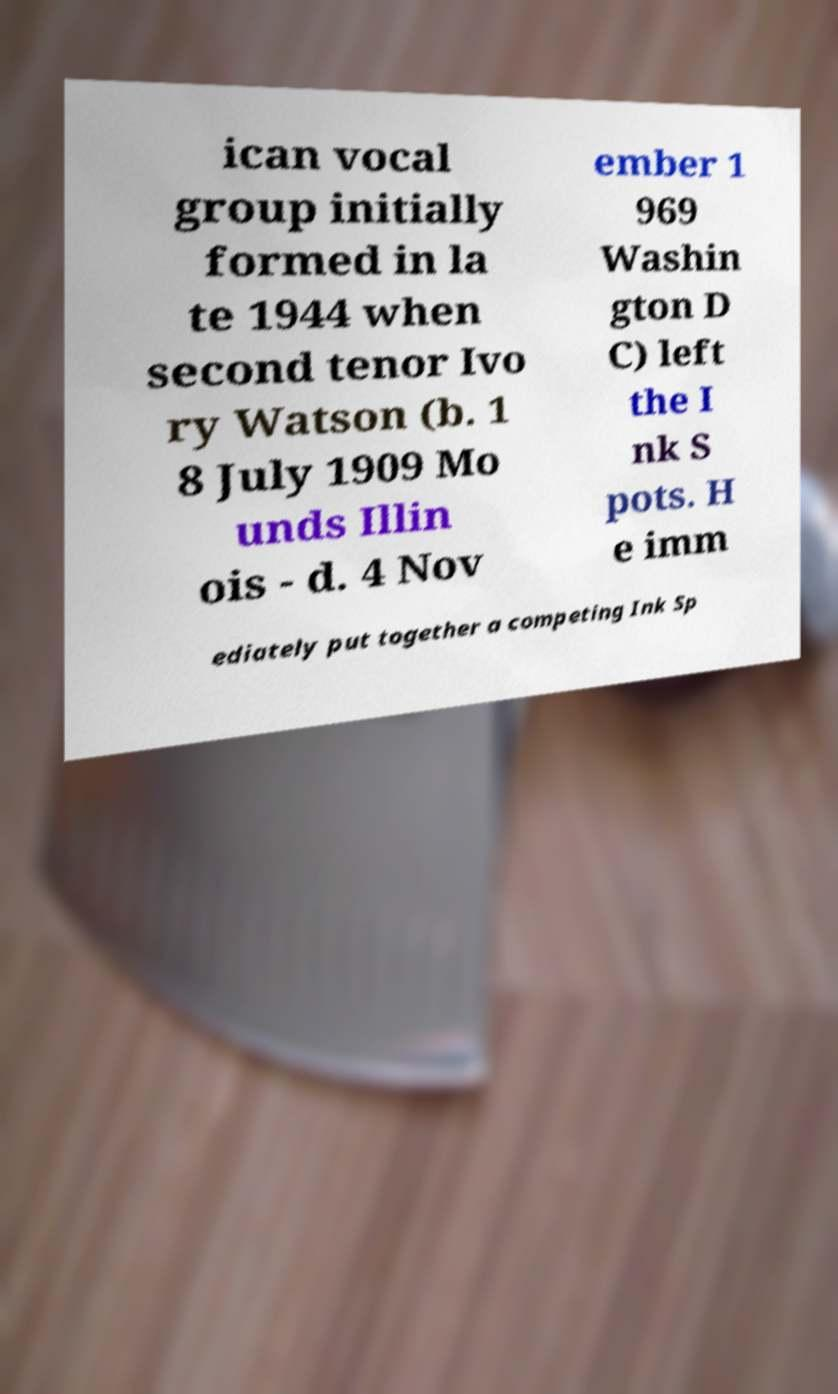Can you read and provide the text displayed in the image?This photo seems to have some interesting text. Can you extract and type it out for me? ican vocal group initially formed in la te 1944 when second tenor Ivo ry Watson (b. 1 8 July 1909 Mo unds Illin ois - d. 4 Nov ember 1 969 Washin gton D C) left the I nk S pots. H e imm ediately put together a competing Ink Sp 